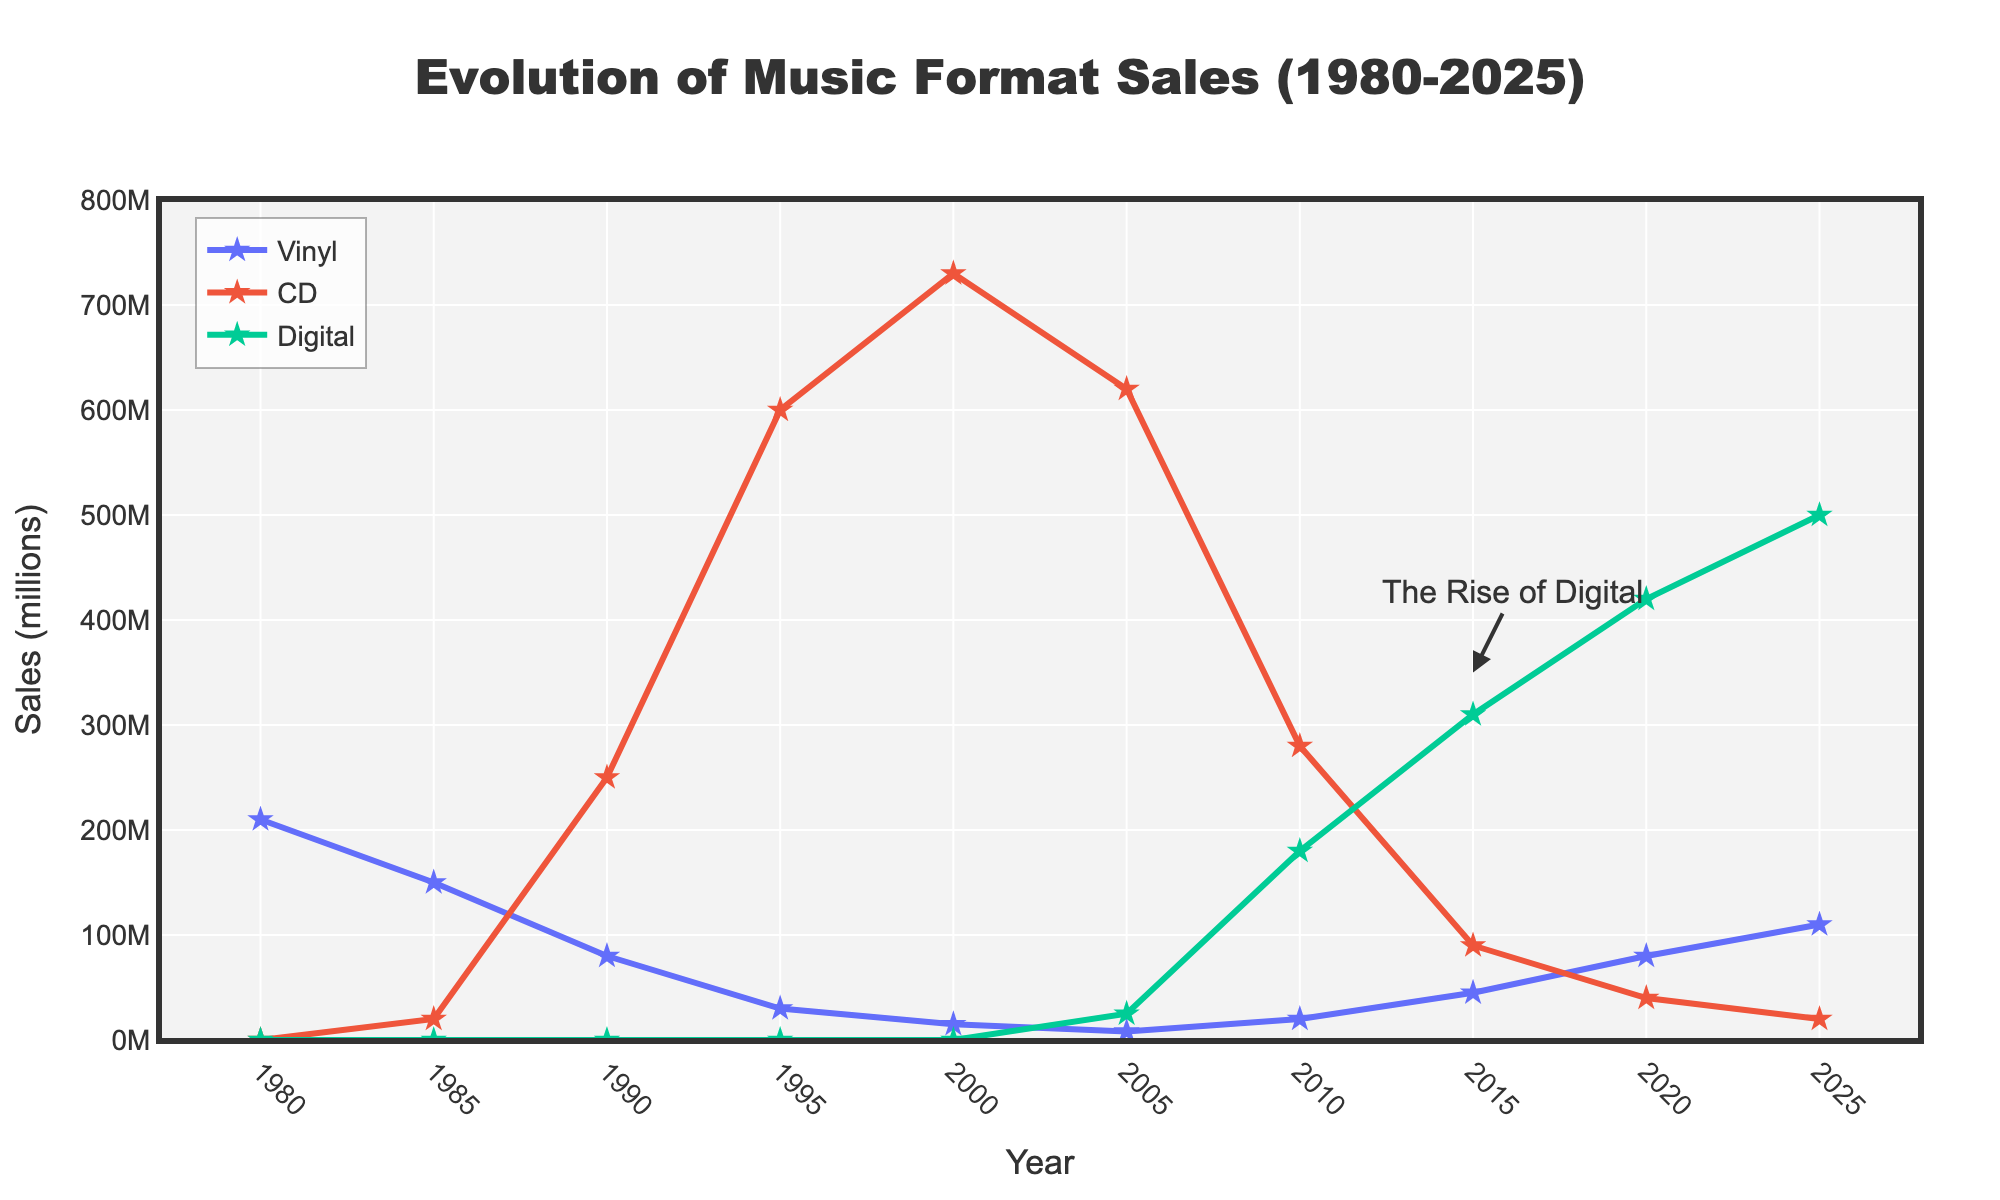Which music format had the highest sales in 2000? To answer this question, check the y-values for the year 2000 across the Vinyl, CD, and Digital lines. The CD line reaches its peak around 730 million sales.
Answer: CD How did vinyl sales change from 1980 to 1990? Observe the Vinyl line at 1980 (210 million) and at 1990 (80 million). Calculate the difference: 210 million - 80 million = 130 million decrease.
Answer: Decreased by 130 million Between which years did CD sales see the most significant decline? Look for the steepest drop in the CD line. The largest drop occurs between 2000 (730 million) and 2010 (280 million).
Answer: 2000 to 2010 What is the combined sales for all formats in 2005? Sum the values for Vinyl (8 million), CD (620 million), and Digital (25 million): 8 + 620 + 25 = 653 million.
Answer: 653 million Which format first reached over 500 million sales and in what year? Check each format's lines for the first year they pass 500 million. The CD line first crosses this threshold in 1995.
Answer: CD in 1995 In what year did digital sales exceed CD sales? Compare the Digital and CD lines and find the crossing point, which occurs in 2015 when Digital is 310 million and CD is 90 million.
Answer: 2015 What can be inferred about the trend of vinyl sales from 2000 to 2025? Observe the Vinyl line from 2000 (15 million) rising to 2025 (110 million), indicating a revival or growing interest in vinyl records.
Answer: Vinyl sales increased How does the total sales trend in the year 2020 compare to 2005? Sum the sales in both years: 2005 (653 million: 8+620+25) and 2020 (540 million: 80+40+420). Sales in 2020 are lower by 113 million (653 - 540).
Answer: Lower in 2020 Which format shows the steadiest increase in sales over the period? Examine the overall trajectory of each line; Digital shows a consistent upward trend from 2005 onwards.
Answer: Digital What is “The Rise of Digital” annotation pointing to in the chart? It points to around 2015, highlighting the significant increase in Digital sales starting around this year.
Answer: 2015 